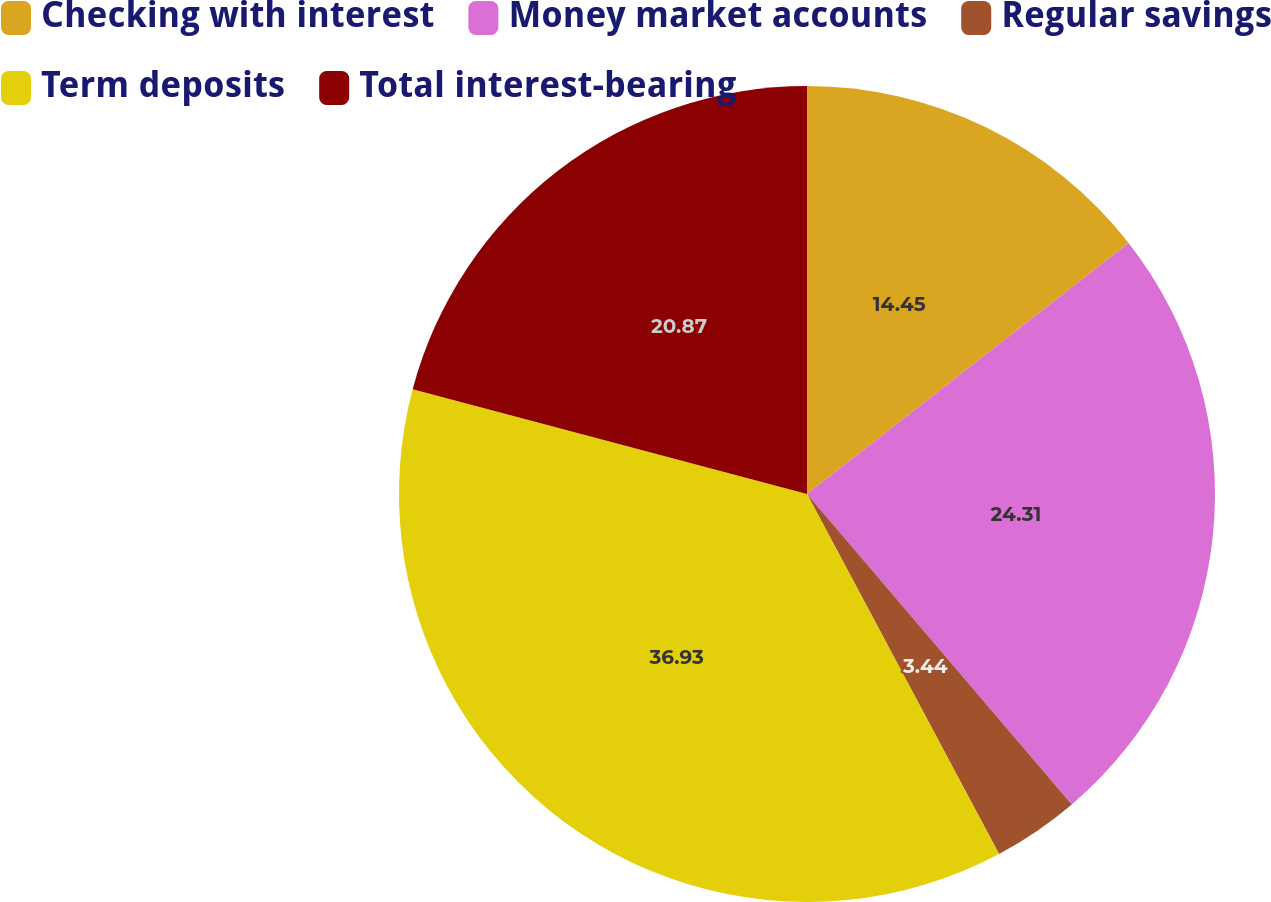<chart> <loc_0><loc_0><loc_500><loc_500><pie_chart><fcel>Checking with interest<fcel>Money market accounts<fcel>Regular savings<fcel>Term deposits<fcel>Total interest-bearing<nl><fcel>14.45%<fcel>24.31%<fcel>3.44%<fcel>36.93%<fcel>20.87%<nl></chart> 